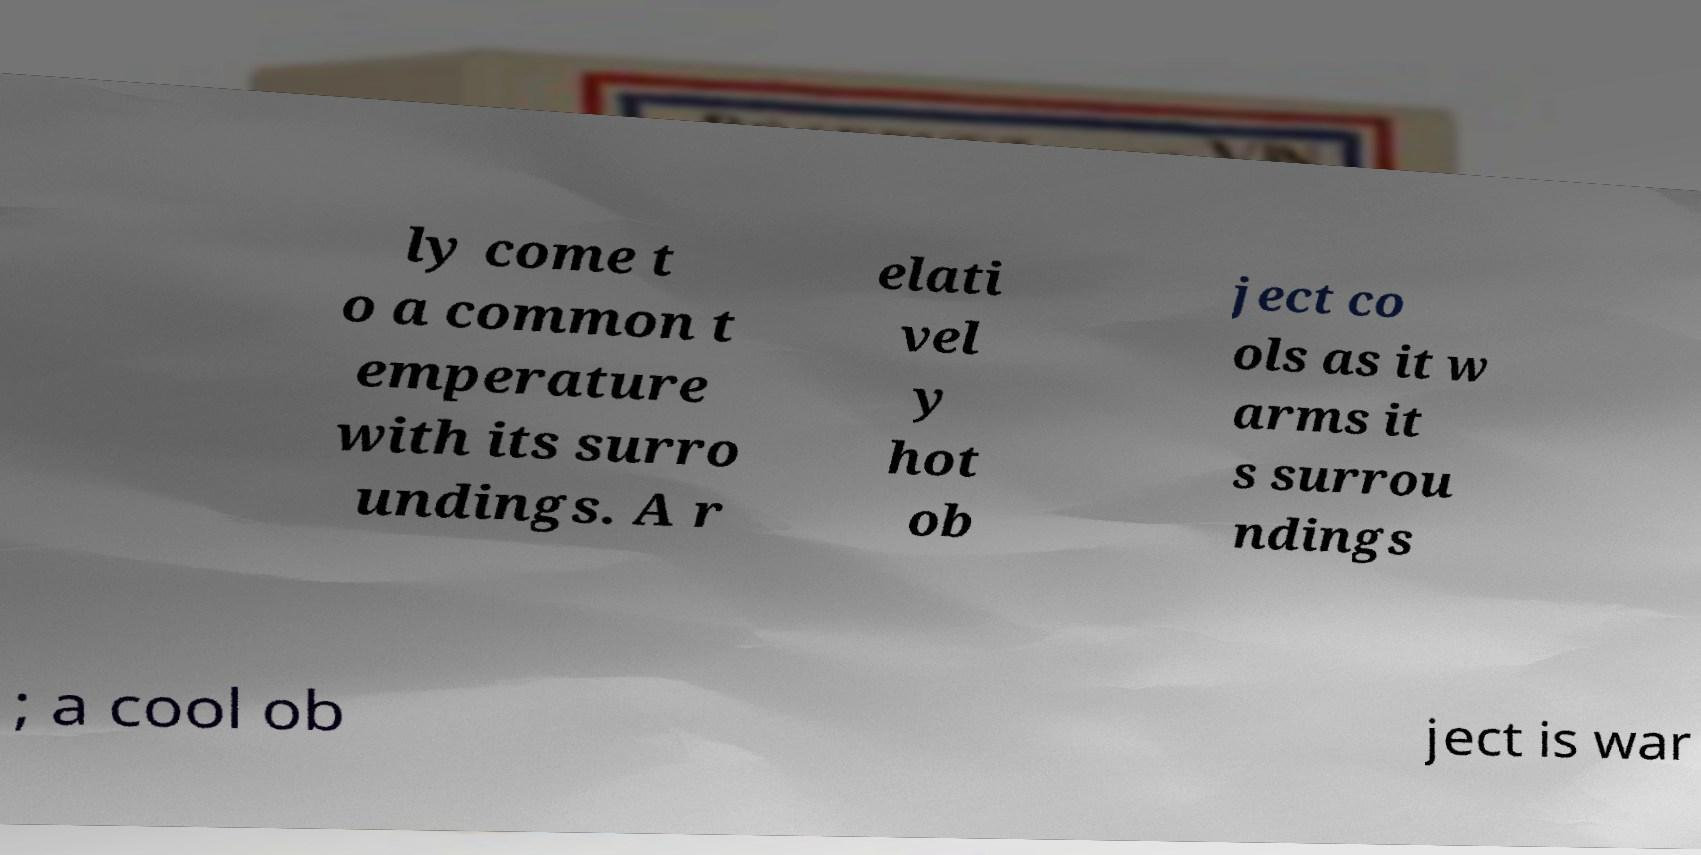I need the written content from this picture converted into text. Can you do that? ly come t o a common t emperature with its surro undings. A r elati vel y hot ob ject co ols as it w arms it s surrou ndings ; a cool ob ject is war 